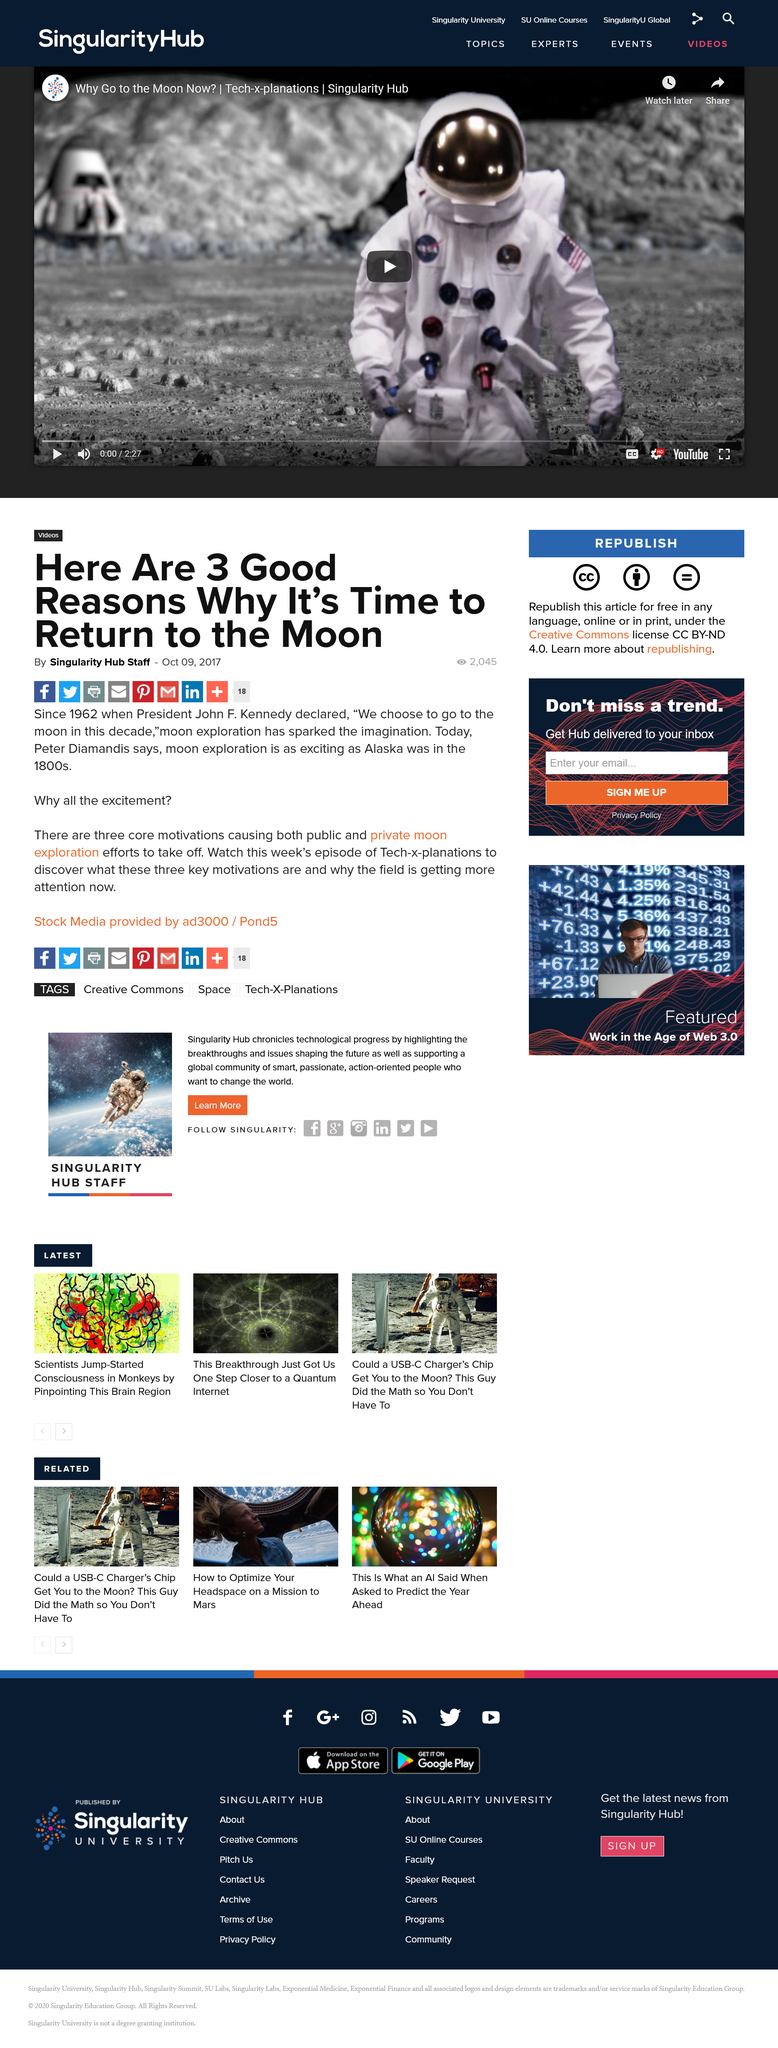Give some essential details in this illustration. In 1962, President John F. Kennedy declared that the United States would choose to go to the moon in this decade. Peter Diamandis compares the excitement of moon exploration to that of Alaska in the 1800s. It is apparent that, according to Tech-x-planations, the three core motivations that indicate it is time to take action are as follows: It is time to return to the moon. 